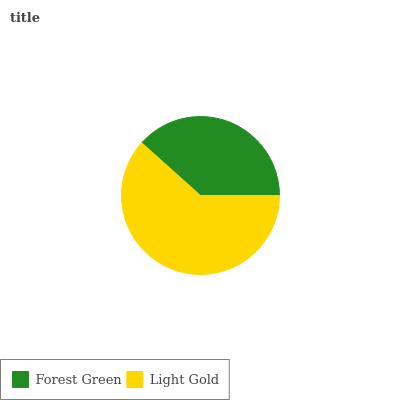Is Forest Green the minimum?
Answer yes or no. Yes. Is Light Gold the maximum?
Answer yes or no. Yes. Is Light Gold the minimum?
Answer yes or no. No. Is Light Gold greater than Forest Green?
Answer yes or no. Yes. Is Forest Green less than Light Gold?
Answer yes or no. Yes. Is Forest Green greater than Light Gold?
Answer yes or no. No. Is Light Gold less than Forest Green?
Answer yes or no. No. Is Light Gold the high median?
Answer yes or no. Yes. Is Forest Green the low median?
Answer yes or no. Yes. Is Forest Green the high median?
Answer yes or no. No. Is Light Gold the low median?
Answer yes or no. No. 